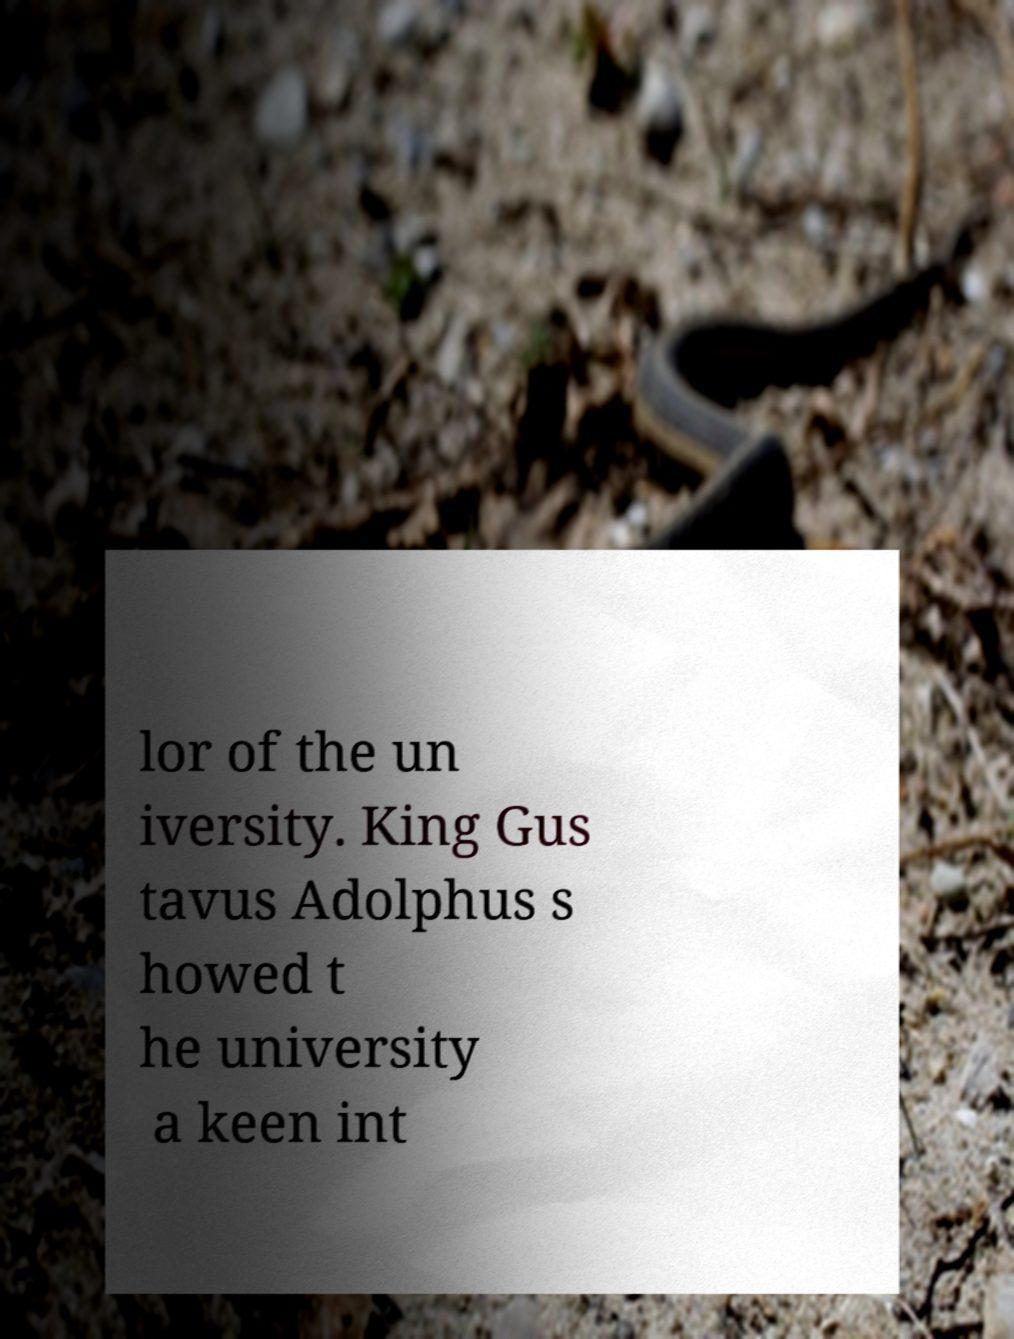Please read and relay the text visible in this image. What does it say? lor of the un iversity. King Gus tavus Adolphus s howed t he university a keen int 